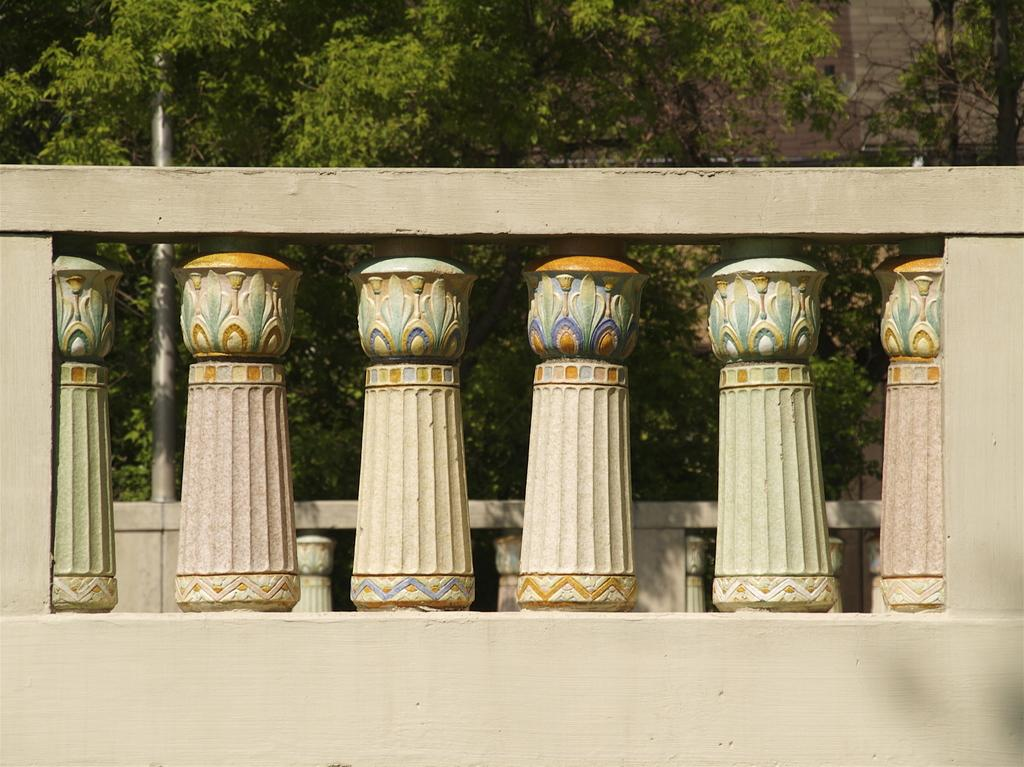What type of structure is visible in the image? There is a wall with pillars in the image. Can you describe the pillars? The pillars have a design on them. What can be seen in the background of the image? There are trees, a building, and a pole in the background of the image. How many frogs are sitting on the pole in the background of the image? There are no frogs present in the image, so it is not possible to determine how many might be sitting on the pole. 